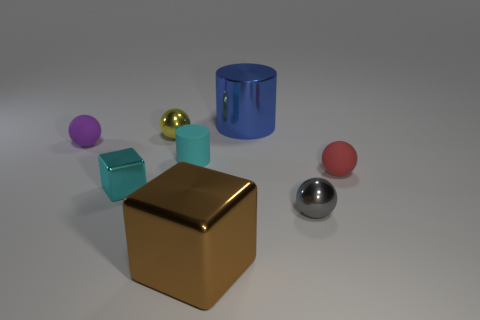What color is the matte cylinder?
Provide a short and direct response. Cyan. Does the shiny object in front of the tiny gray shiny object have the same shape as the big object behind the red sphere?
Provide a succinct answer. No. There is a cylinder that is in front of the tiny purple thing; what is its color?
Keep it short and to the point. Cyan. Is the number of shiny spheres on the left side of the big shiny cube less than the number of yellow metal things on the right side of the blue shiny thing?
Keep it short and to the point. No. How many other things are the same material as the red ball?
Keep it short and to the point. 2. Is the material of the tiny gray sphere the same as the tiny yellow sphere?
Provide a succinct answer. Yes. How many other things are the same size as the yellow object?
Provide a succinct answer. 5. Is the number of small brown matte cylinders the same as the number of rubber cylinders?
Your answer should be very brief. No. What size is the metallic sphere behind the small rubber ball that is right of the cyan matte cylinder?
Offer a very short reply. Small. There is a cylinder behind the tiny shiny sphere that is behind the small matte sphere that is right of the tiny purple ball; what is its color?
Your response must be concise. Blue. 